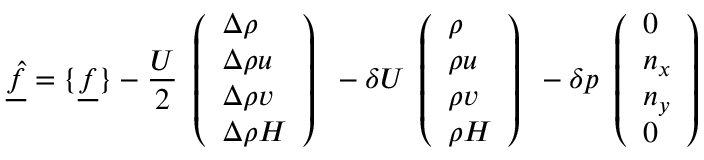<formula> <loc_0><loc_0><loc_500><loc_500>\underline { { \hat { f } } } = \{ \underline { f } \} - \frac { U } { 2 } \begin{array} { l } { \left ( \begin{array} { l } { \Delta \rho } \\ { \Delta \rho u } \\ { \Delta \rho v } \\ { \Delta \rho H } \end{array} \right ) } \end{array} - \delta U \begin{array} { l } { \left ( \begin{array} { l } { \rho } \\ { \rho u } \\ { \rho v } \\ { \rho H } \end{array} \right ) } \end{array} - \delta p \begin{array} { l } { \left ( \begin{array} { l } { 0 } \\ { n _ { x } } \\ { n _ { y } } \\ { 0 } \end{array} \right ) } \end{array}</formula> 